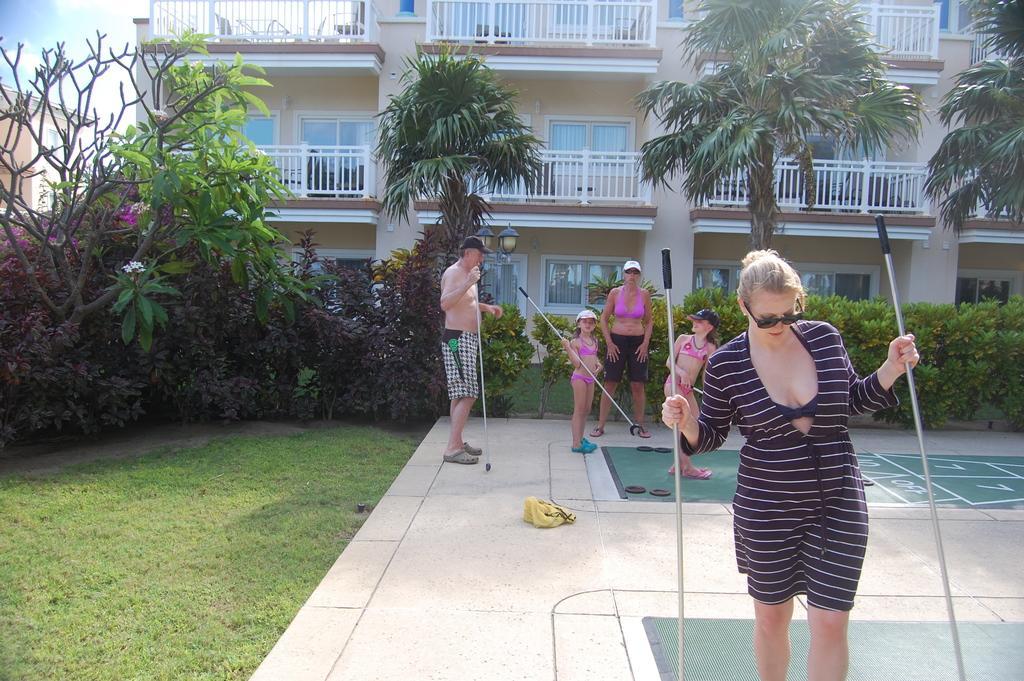Could you give a brief overview of what you see in this image? This is an outside view. Here I can see few people are standing by holding some sticks in the hands. On the the left side, I can see green color grass. In the background there are some trees, plants and a building. On the top left corner of the image I can see the sky. 